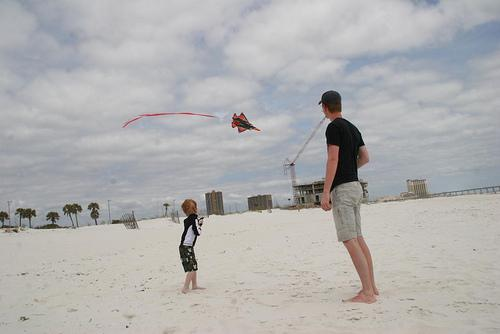Question: who is flying the kite?
Choices:
A. A little boy.
B. A young man.
C. A little girl.
D. A father and son.
Answer with the letter. Answer: A Question: where is the location?
Choices:
A. Bay.
B. Harbor.
C. Beach.
D. The pennisula.
Answer with the letter. Answer: C Question: what is the kite shaped like?
Choices:
A. Dragon.
B. Bird.
C. Plane.
D. Rocket.
Answer with the letter. Answer: C Question: why is the little boy holding the string?
Choices:
A. Playing with his yoyo.
B. He needs to tie a package.
C. Holding his balloon with it.
D. Flying a kite with it.
Answer with the letter. Answer: D 